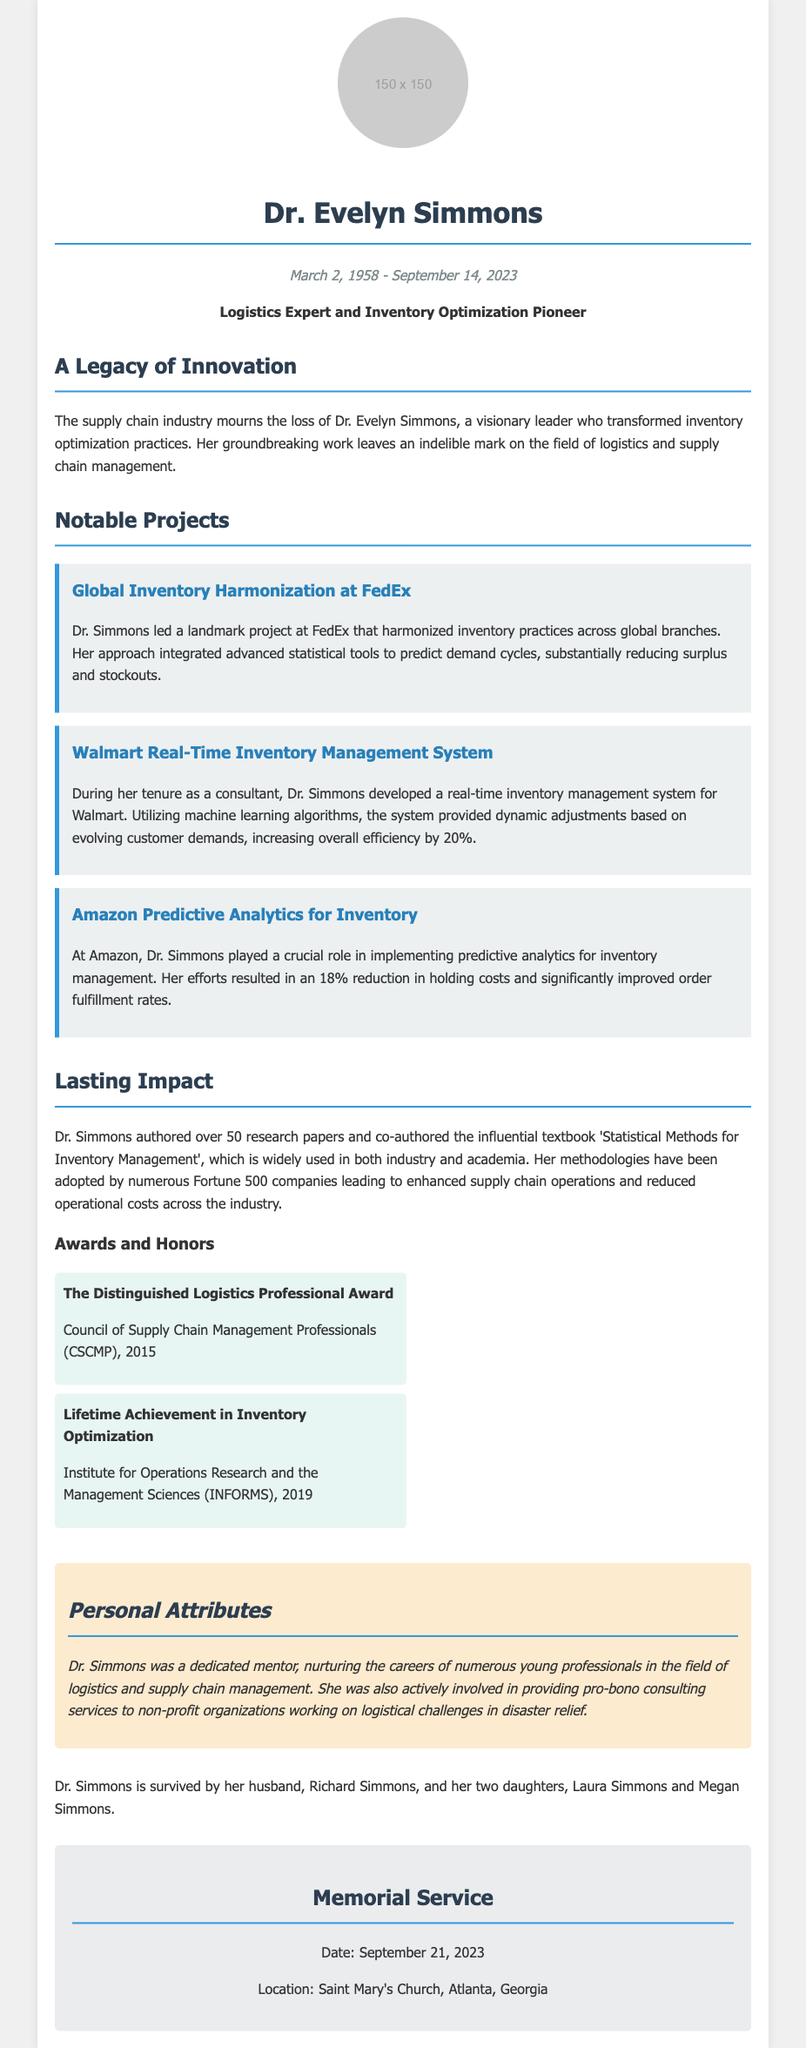What was Dr. Evelyn Simmons' profession? The document states that she was a "Logistics Expert and Inventory Optimization Pioneer."
Answer: Logistics Expert and Inventory Optimization Pioneer When did Dr. Evelyn Simmons pass away? The date of her passing is mentioned in the document as September 14, 2023.
Answer: September 14, 2023 What was the title of the influential textbook authored by Dr. Simmons? The title is specifically provided as 'Statistical Methods for Inventory Management.'
Answer: Statistical Methods for Inventory Management How much did Dr. Simmons increase efficiency at Walmart with her management system? The document notes a "20%" increase in overall efficiency due to her system.
Answer: 20% What award did Dr. Simmons receive in 2019? The document lists her as the recipient of the "Lifetime Achievement in Inventory Optimization."
Answer: Lifetime Achievement in Inventory Optimization Which logistics company was involved in Dr. Simmons' Global Inventory Harmonization project? The project mentioned took place at FedEx as stated in the document.
Answer: FedEx How many daughters did Dr. Simmons have? The document states she is survived by "two daughters."
Answer: Two What was the date of the memorial service for Dr. Simmons? The document specifies the date of the memorial service as September 21, 2023.
Answer: September 21, 2023 What role did Dr. Simmons play in disaster relief? The document states she was involved in providing "pro-bono consulting services to non-profit organizations."
Answer: Pro-bono consulting services to non-profit organizations 